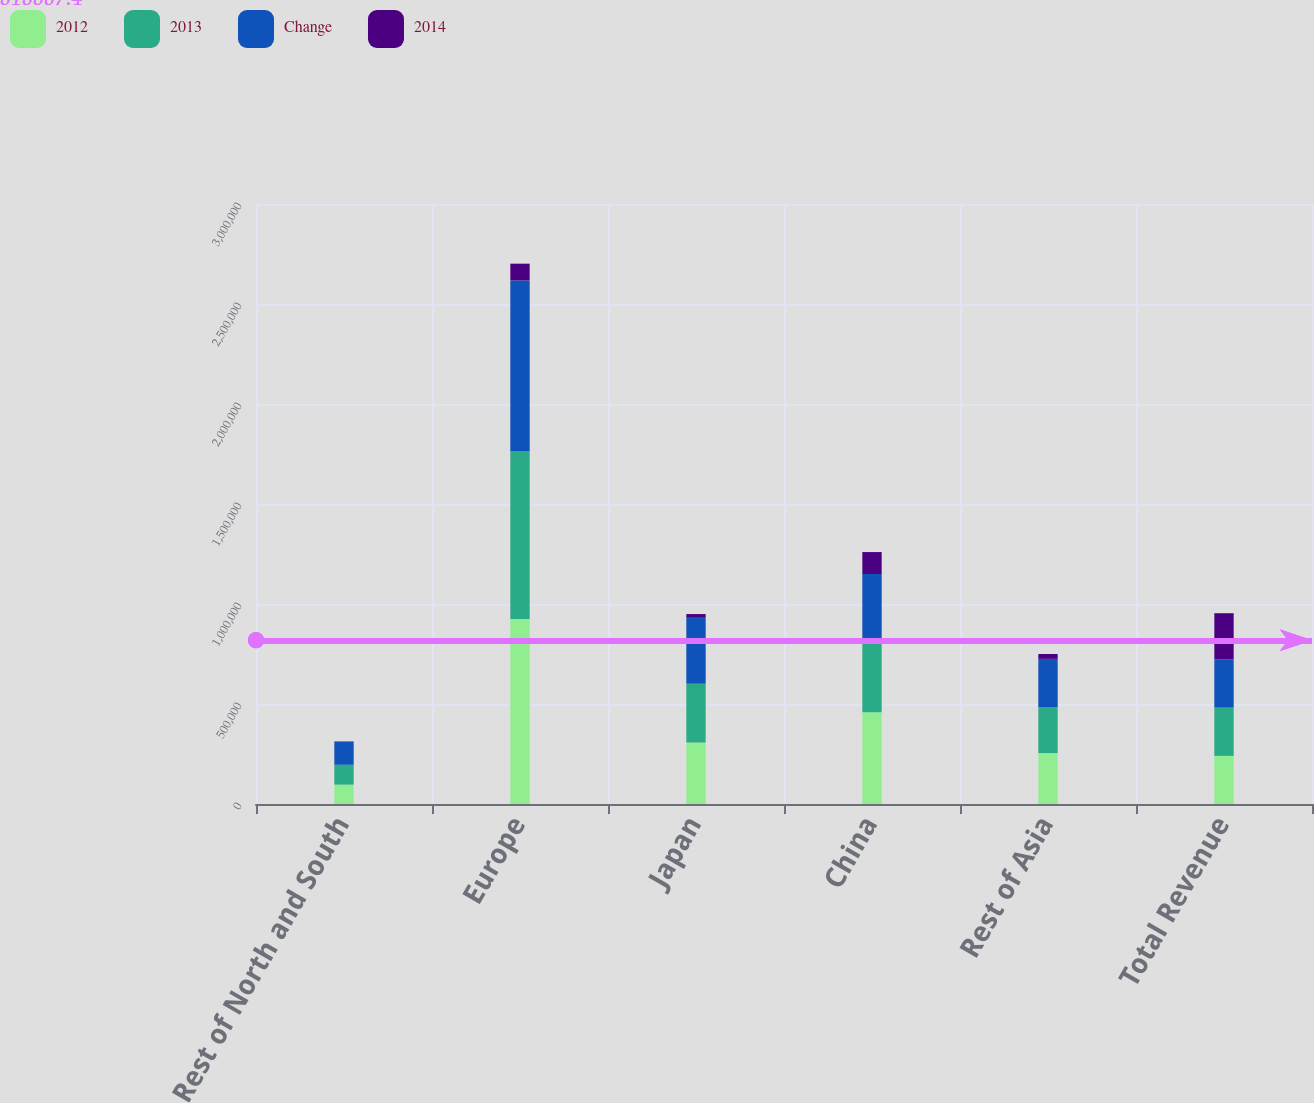Convert chart. <chart><loc_0><loc_0><loc_500><loc_500><stacked_bar_chart><ecel><fcel>Rest of North and South<fcel>Europe<fcel>Japan<fcel>China<fcel>Rest of Asia<fcel>Total Revenue<nl><fcel>2012<fcel>96957<fcel>924477<fcel>308054<fcel>459260<fcel>254471<fcel>240934<nl><fcel>2013<fcel>99215<fcel>840585<fcel>292804<fcel>349575<fcel>230241<fcel>240934<nl><fcel>Change<fcel>114133<fcel>852668<fcel>333558<fcel>341196<fcel>240934<fcel>240934<nl><fcel>2014<fcel>2258<fcel>83892<fcel>15250<fcel>109685<fcel>24230<fcel>231084<nl></chart> 